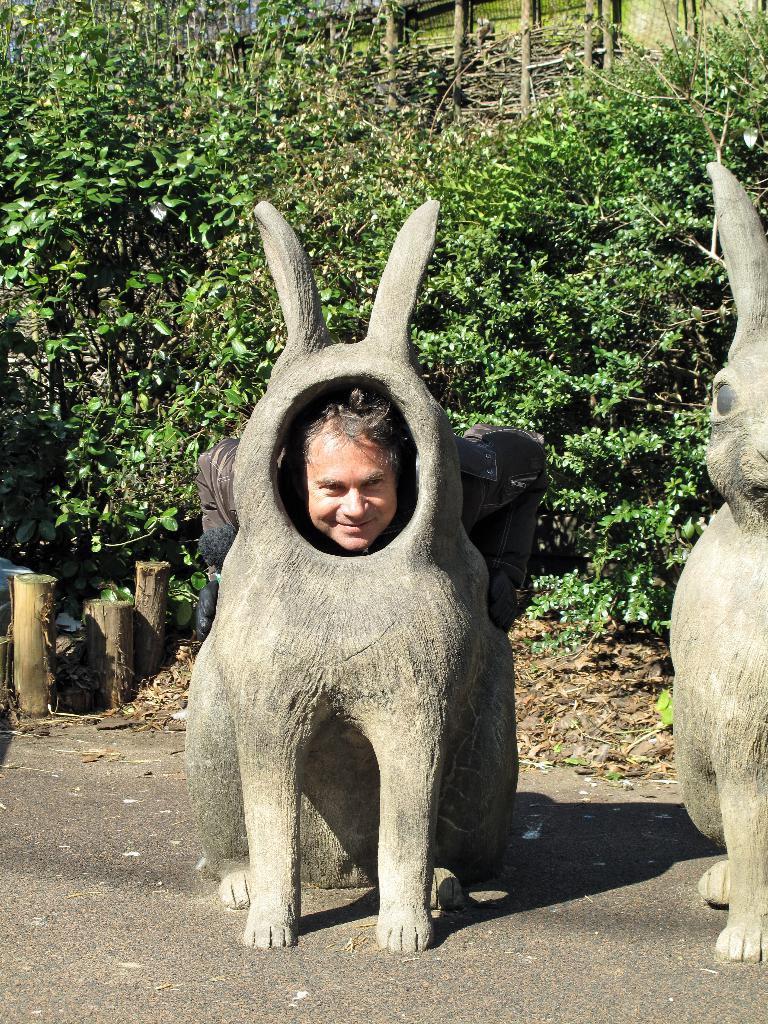Could you give a brief overview of what you see in this image? There is a rabbit statue on the right side of the image and a man inside the rabbit statue in the center, there is greenery in the background and small bamboos on the left side. 